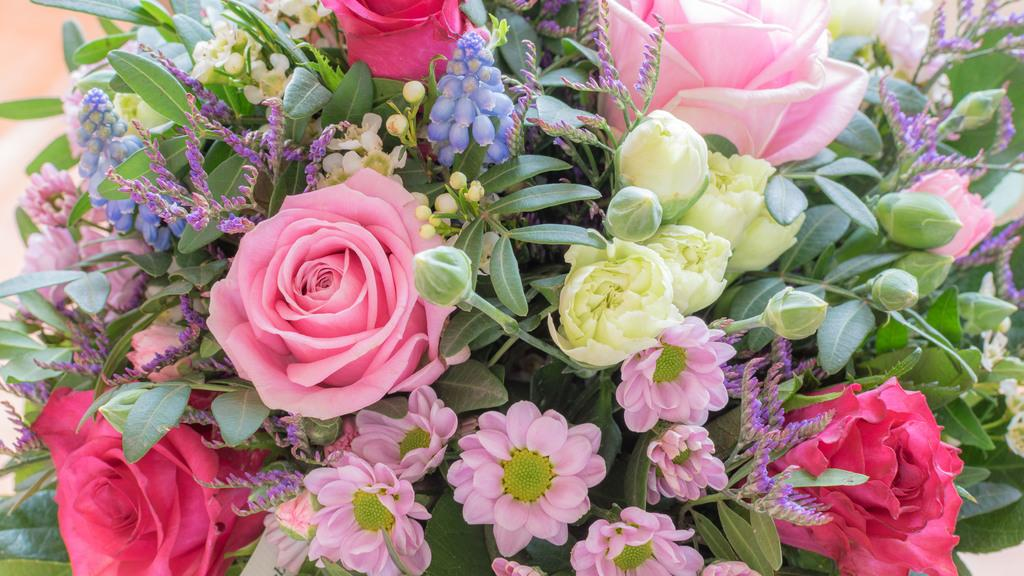What type of plants can be seen in the image? There are colorful flowers in the image. Can you describe the growth stage of some of the flowers? Yes, there are buds in the image. What else is present on the plants besides flowers? There are leaves in the image. What type of glass is being used to protect the flowers in the image? There is no glass present in the image; the flowers are not protected by any glass. 